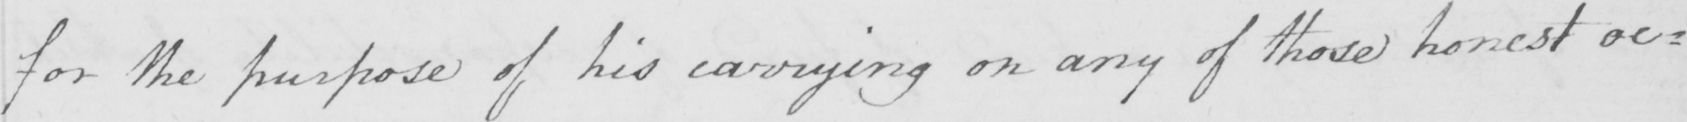What text is written in this handwritten line? for the purpose of his carrying on any of those honest oc= 